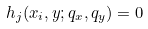Convert formula to latex. <formula><loc_0><loc_0><loc_500><loc_500>h _ { j } ( x _ { i } , y ; q _ { x } , q _ { y } ) = 0</formula> 